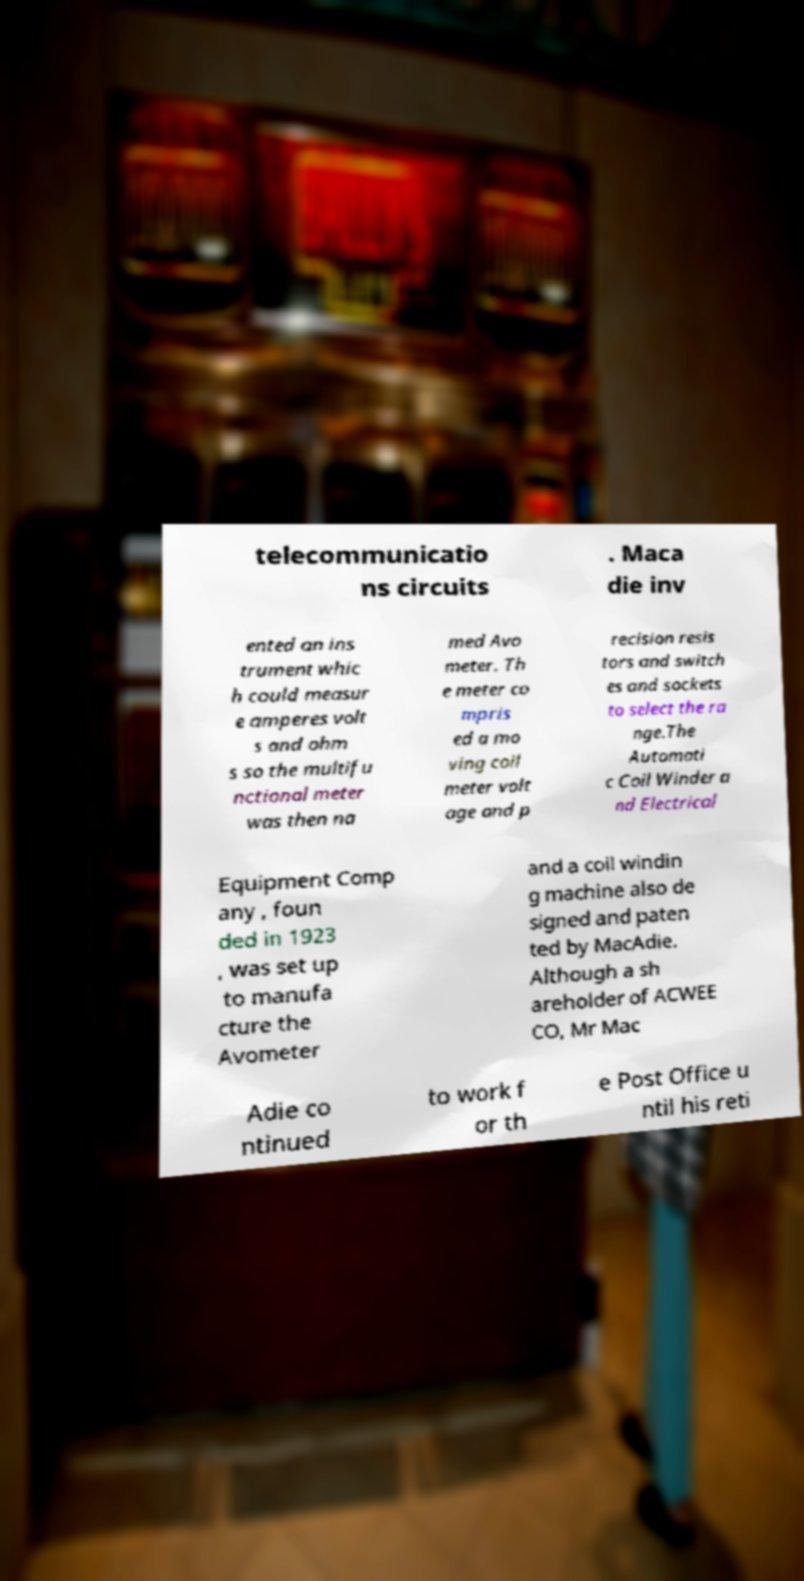Please read and relay the text visible in this image. What does it say? telecommunicatio ns circuits . Maca die inv ented an ins trument whic h could measur e amperes volt s and ohm s so the multifu nctional meter was then na med Avo meter. Th e meter co mpris ed a mo ving coil meter volt age and p recision resis tors and switch es and sockets to select the ra nge.The Automati c Coil Winder a nd Electrical Equipment Comp any , foun ded in 1923 , was set up to manufa cture the Avometer and a coil windin g machine also de signed and paten ted by MacAdie. Although a sh areholder of ACWEE CO, Mr Mac Adie co ntinued to work f or th e Post Office u ntil his reti 